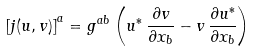<formula> <loc_0><loc_0><loc_500><loc_500>\left [ j ( u , v ) \right ] ^ { a } = g ^ { a b } \left ( u ^ { * } \, \frac { \partial v } { \partial x _ { b } } - v \, \frac { \partial u ^ { * } } { \partial x _ { b } } \right )</formula> 